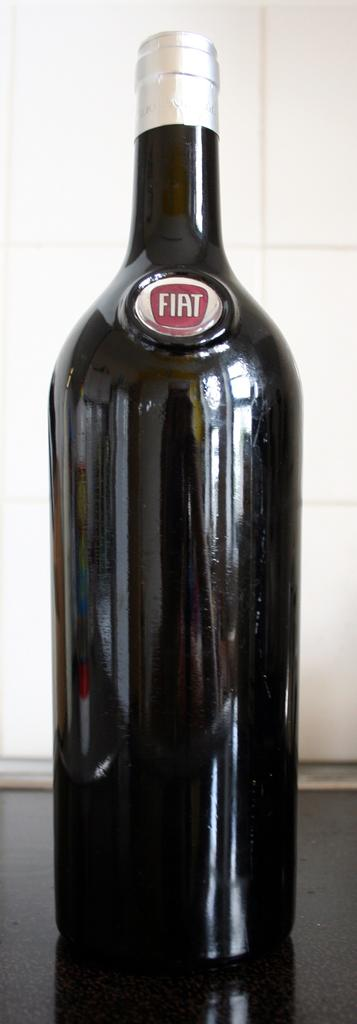<image>
Create a compact narrative representing the image presented. A bottle with the car brand FIAT on it. 